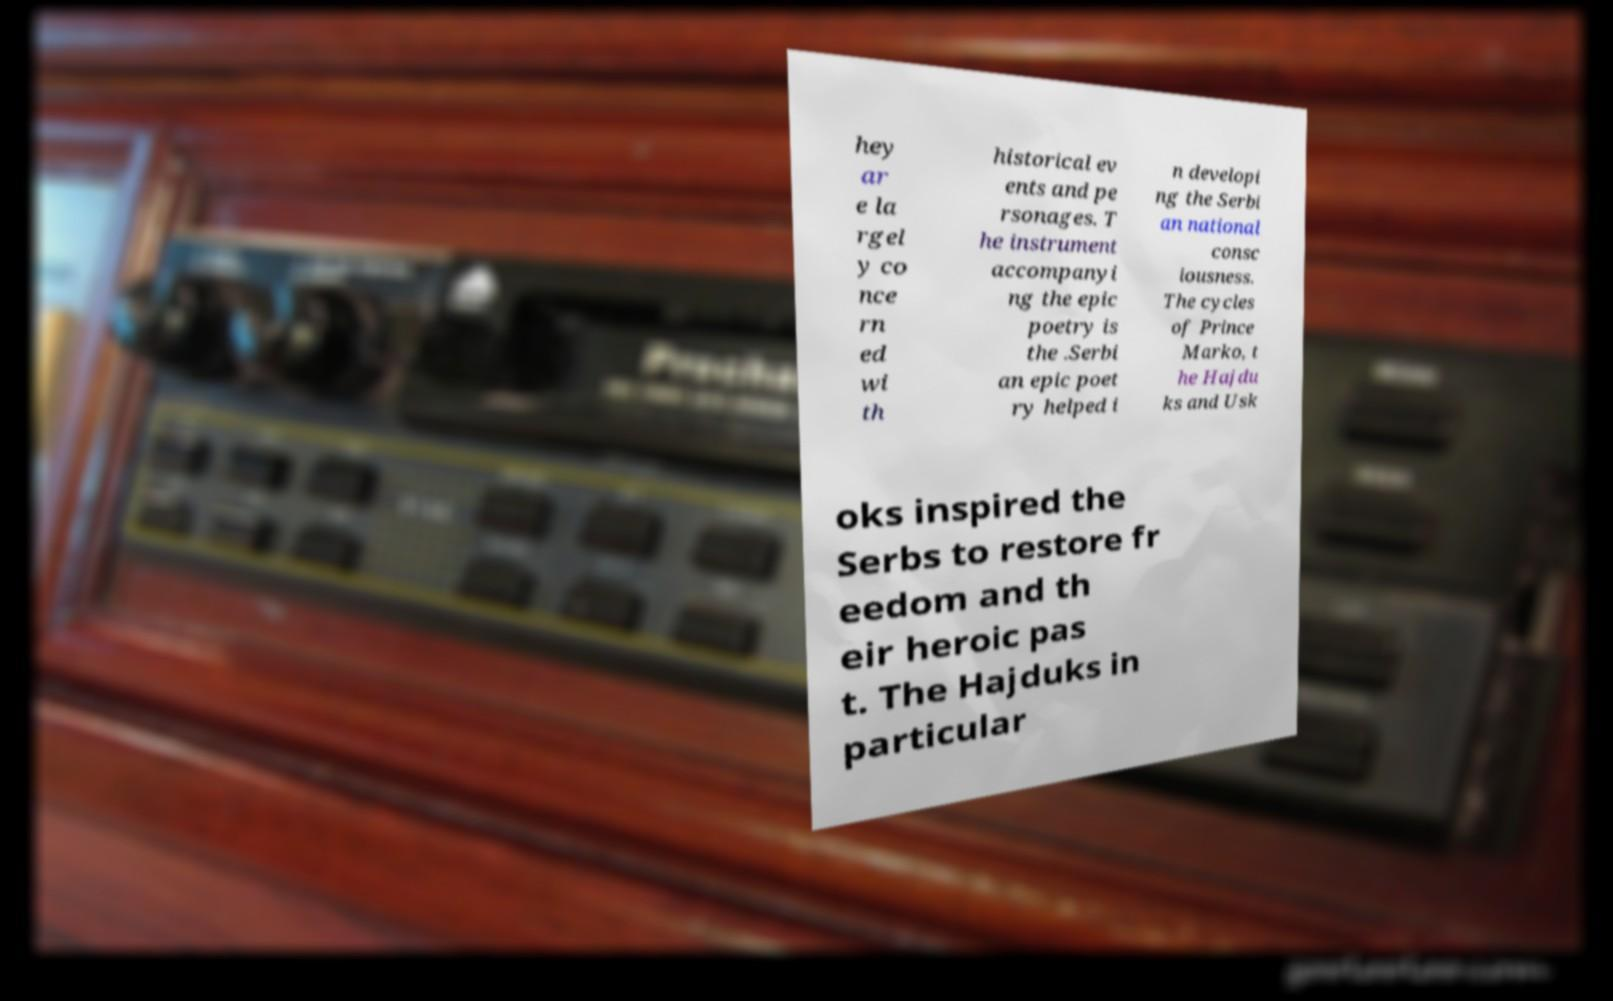I need the written content from this picture converted into text. Can you do that? hey ar e la rgel y co nce rn ed wi th historical ev ents and pe rsonages. T he instrument accompanyi ng the epic poetry is the .Serbi an epic poet ry helped i n developi ng the Serbi an national consc iousness. The cycles of Prince Marko, t he Hajdu ks and Usk oks inspired the Serbs to restore fr eedom and th eir heroic pas t. The Hajduks in particular 